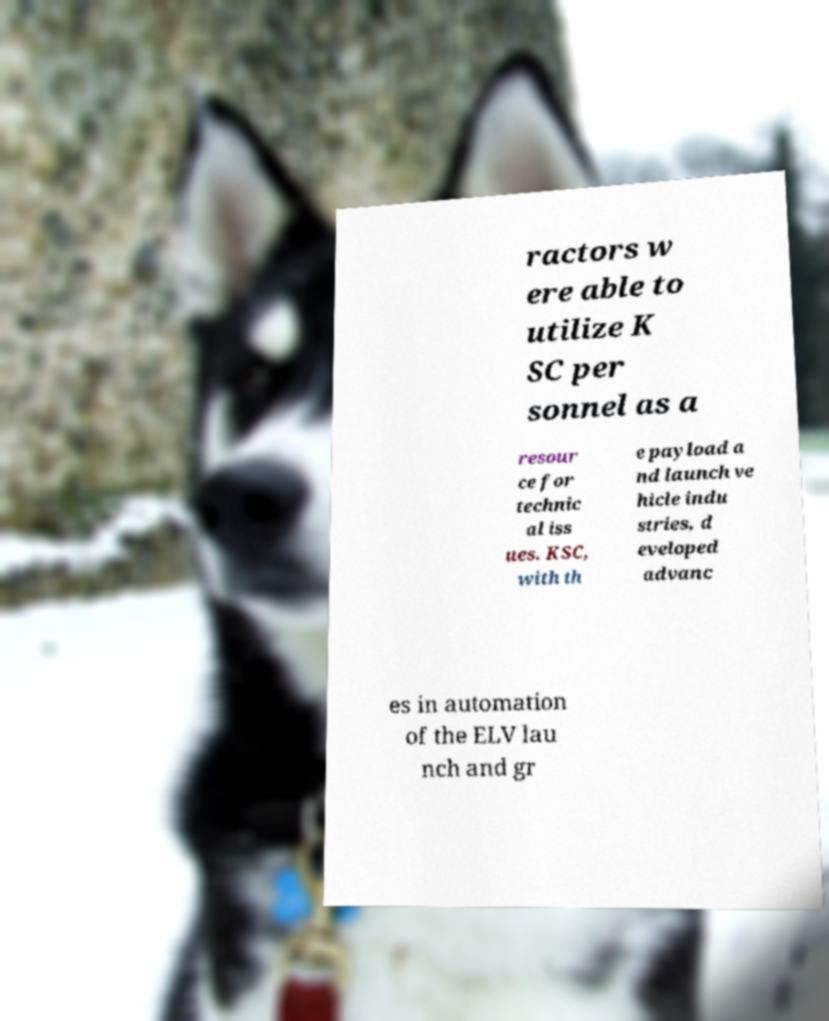Could you extract and type out the text from this image? ractors w ere able to utilize K SC per sonnel as a resour ce for technic al iss ues. KSC, with th e payload a nd launch ve hicle indu stries, d eveloped advanc es in automation of the ELV lau nch and gr 